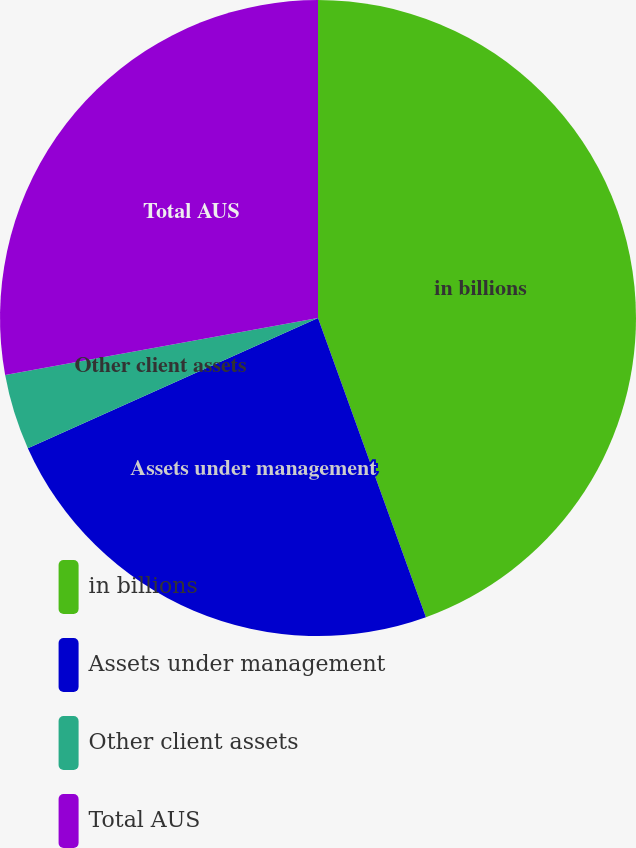Convert chart to OTSL. <chart><loc_0><loc_0><loc_500><loc_500><pie_chart><fcel>in billions<fcel>Assets under management<fcel>Other client assets<fcel>Total AUS<nl><fcel>44.49%<fcel>23.8%<fcel>3.84%<fcel>27.87%<nl></chart> 